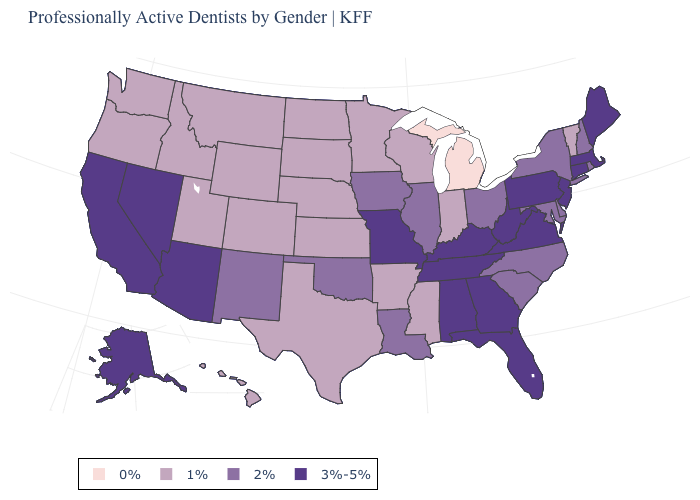Among the states that border Wyoming , which have the highest value?
Write a very short answer. Colorado, Idaho, Montana, Nebraska, South Dakota, Utah. What is the value of Connecticut?
Short answer required. 3%-5%. Is the legend a continuous bar?
Quick response, please. No. What is the value of Tennessee?
Be succinct. 3%-5%. Among the states that border Missouri , which have the lowest value?
Be succinct. Arkansas, Kansas, Nebraska. What is the highest value in the USA?
Be succinct. 3%-5%. Name the states that have a value in the range 1%?
Be succinct. Arkansas, Colorado, Hawaii, Idaho, Indiana, Kansas, Minnesota, Mississippi, Montana, Nebraska, North Dakota, Oregon, South Dakota, Texas, Utah, Vermont, Washington, Wisconsin, Wyoming. What is the value of Arizona?
Answer briefly. 3%-5%. Name the states that have a value in the range 1%?
Write a very short answer. Arkansas, Colorado, Hawaii, Idaho, Indiana, Kansas, Minnesota, Mississippi, Montana, Nebraska, North Dakota, Oregon, South Dakota, Texas, Utah, Vermont, Washington, Wisconsin, Wyoming. Among the states that border Virginia , does Kentucky have the highest value?
Short answer required. Yes. Does the first symbol in the legend represent the smallest category?
Short answer required. Yes. What is the value of Pennsylvania?
Give a very brief answer. 3%-5%. Name the states that have a value in the range 2%?
Concise answer only. Delaware, Illinois, Iowa, Louisiana, Maryland, New Hampshire, New Mexico, New York, North Carolina, Ohio, Oklahoma, Rhode Island, South Carolina. What is the value of Virginia?
Be succinct. 3%-5%. 